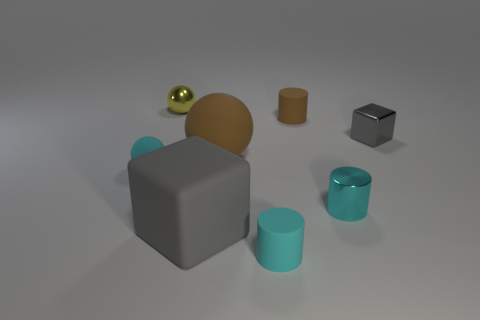What number of things are either small cyan objects on the right side of the small cyan ball or cyan rubber things in front of the tiny cyan metallic cylinder?
Your answer should be very brief. 2. Do the yellow object and the gray thing that is behind the large gray thing have the same shape?
Your response must be concise. No. What is the shape of the brown thing that is on the right side of the big rubber thing that is on the right side of the gray block left of the cyan metal cylinder?
Provide a succinct answer. Cylinder. How many other things are made of the same material as the big brown ball?
Offer a very short reply. 4. What number of objects are either matte spheres that are to the right of the tiny yellow ball or large cyan matte blocks?
Provide a short and direct response. 1. What is the shape of the matte object that is to the left of the tiny thing behind the small brown matte thing?
Offer a very short reply. Sphere. There is a big gray object that is in front of the tiny brown matte cylinder; is it the same shape as the small brown object?
Your response must be concise. No. There is a rubber cylinder that is in front of the gray matte object; what color is it?
Ensure brevity in your answer.  Cyan. What number of cylinders are gray things or cyan metal objects?
Keep it short and to the point. 1. There is a gray thing that is in front of the small thing left of the yellow metal thing; what size is it?
Your answer should be compact. Large. 